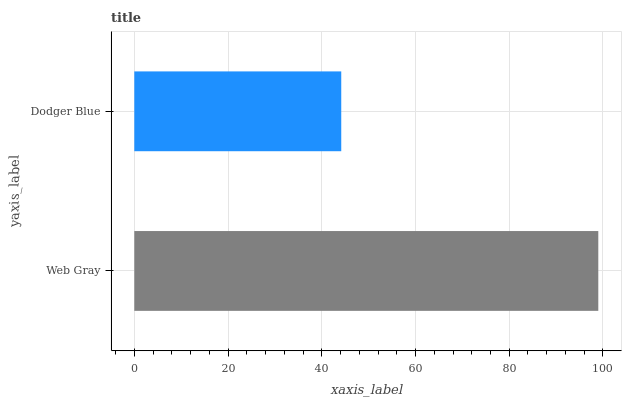Is Dodger Blue the minimum?
Answer yes or no. Yes. Is Web Gray the maximum?
Answer yes or no. Yes. Is Dodger Blue the maximum?
Answer yes or no. No. Is Web Gray greater than Dodger Blue?
Answer yes or no. Yes. Is Dodger Blue less than Web Gray?
Answer yes or no. Yes. Is Dodger Blue greater than Web Gray?
Answer yes or no. No. Is Web Gray less than Dodger Blue?
Answer yes or no. No. Is Web Gray the high median?
Answer yes or no. Yes. Is Dodger Blue the low median?
Answer yes or no. Yes. Is Dodger Blue the high median?
Answer yes or no. No. Is Web Gray the low median?
Answer yes or no. No. 